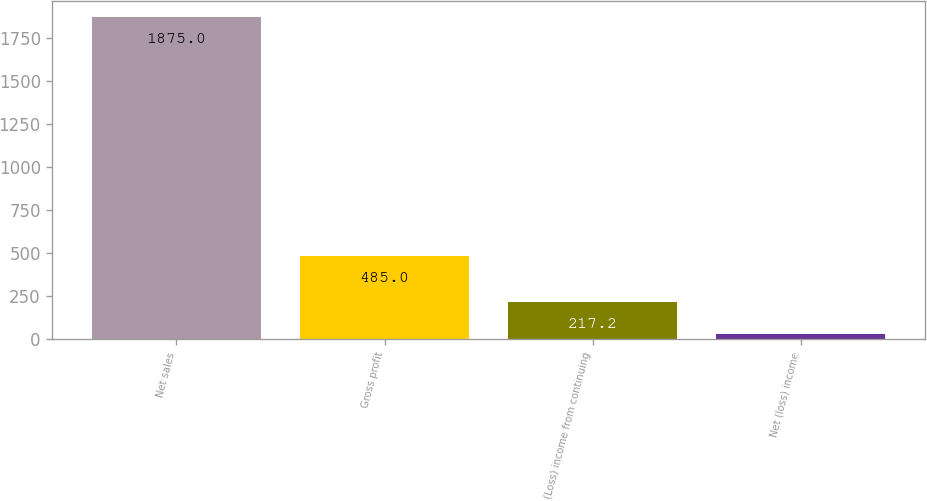<chart> <loc_0><loc_0><loc_500><loc_500><bar_chart><fcel>Net sales<fcel>Gross profit<fcel>(Loss) income from continuing<fcel>Net (loss) income<nl><fcel>1875<fcel>485<fcel>217.2<fcel>33<nl></chart> 